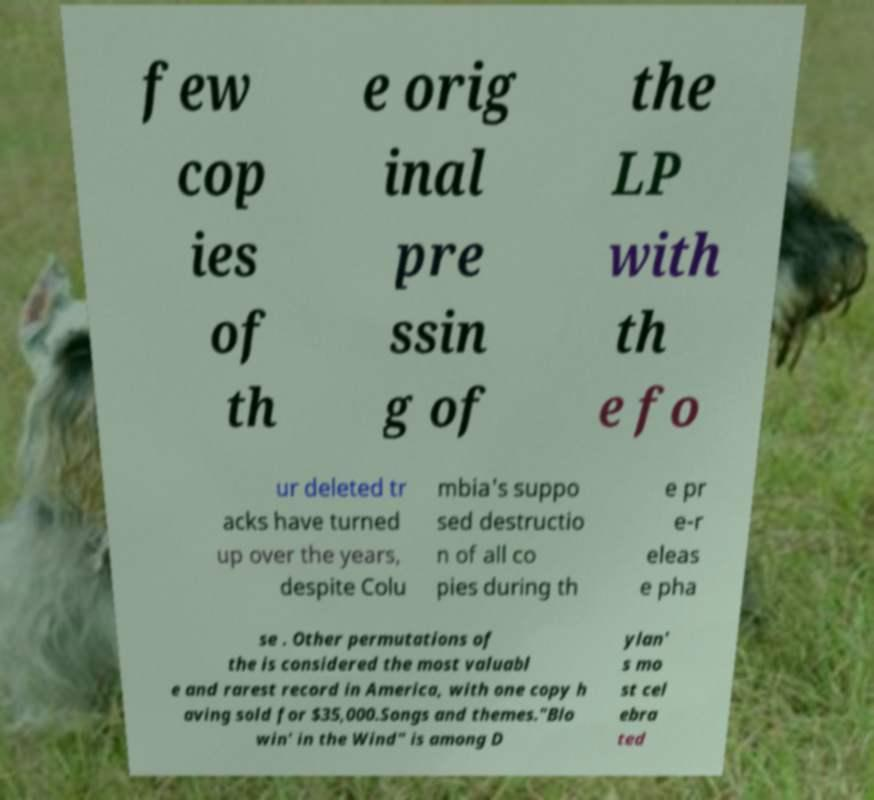Please identify and transcribe the text found in this image. few cop ies of th e orig inal pre ssin g of the LP with th e fo ur deleted tr acks have turned up over the years, despite Colu mbia's suppo sed destructio n of all co pies during th e pr e-r eleas e pha se . Other permutations of the is considered the most valuabl e and rarest record in America, with one copy h aving sold for $35,000.Songs and themes."Blo win' in the Wind" is among D ylan' s mo st cel ebra ted 